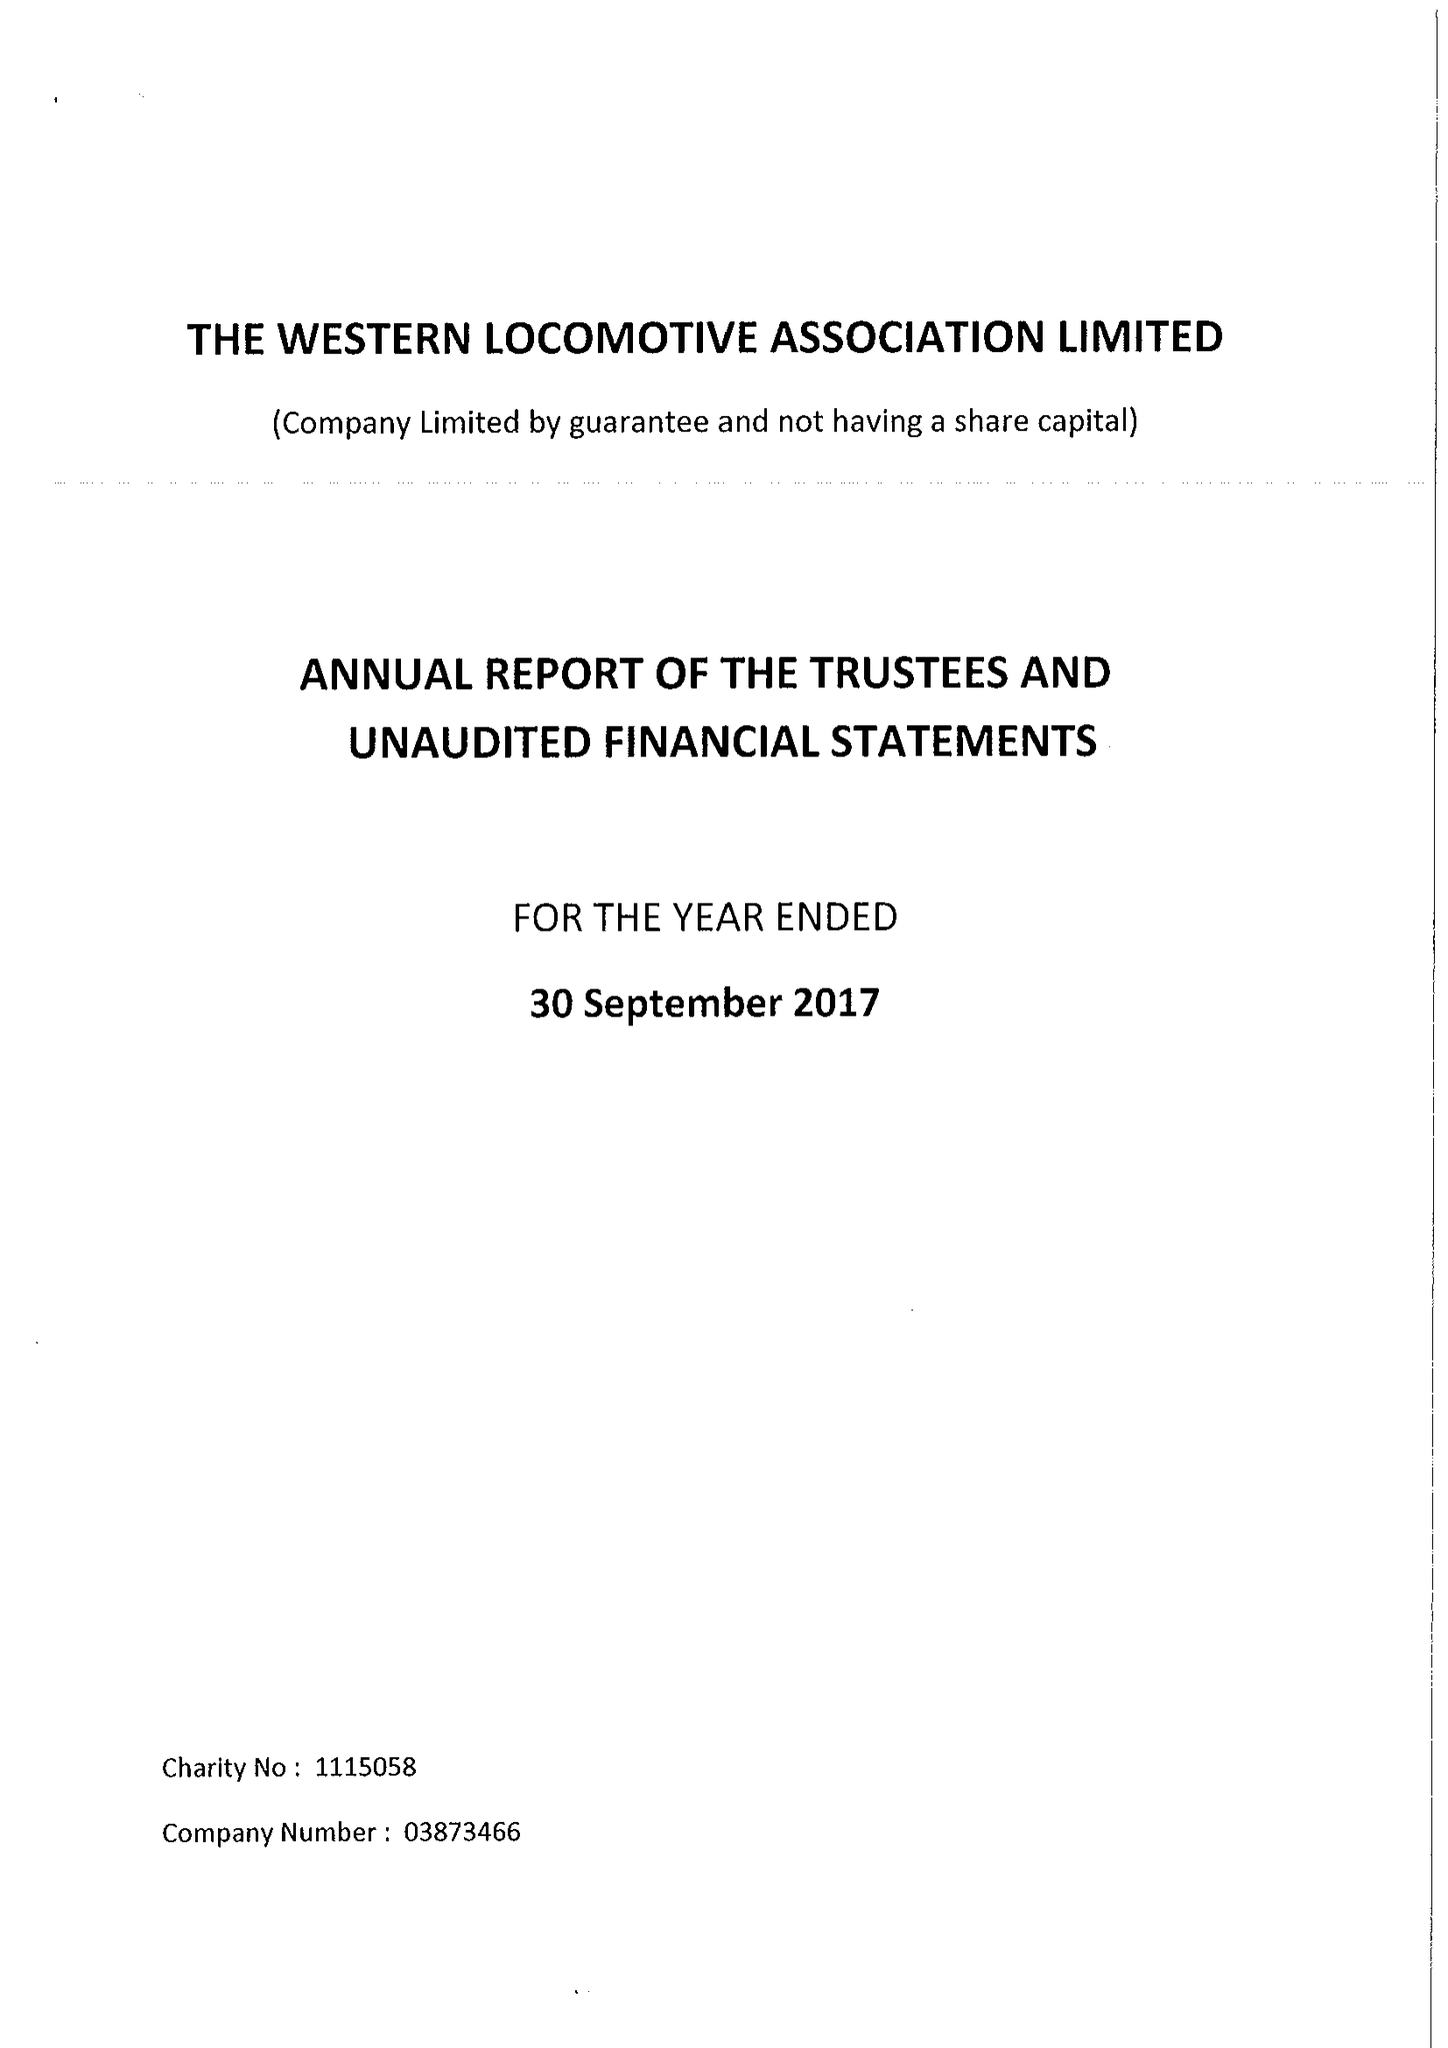What is the value for the income_annually_in_british_pounds?
Answer the question using a single word or phrase. 49828.00 